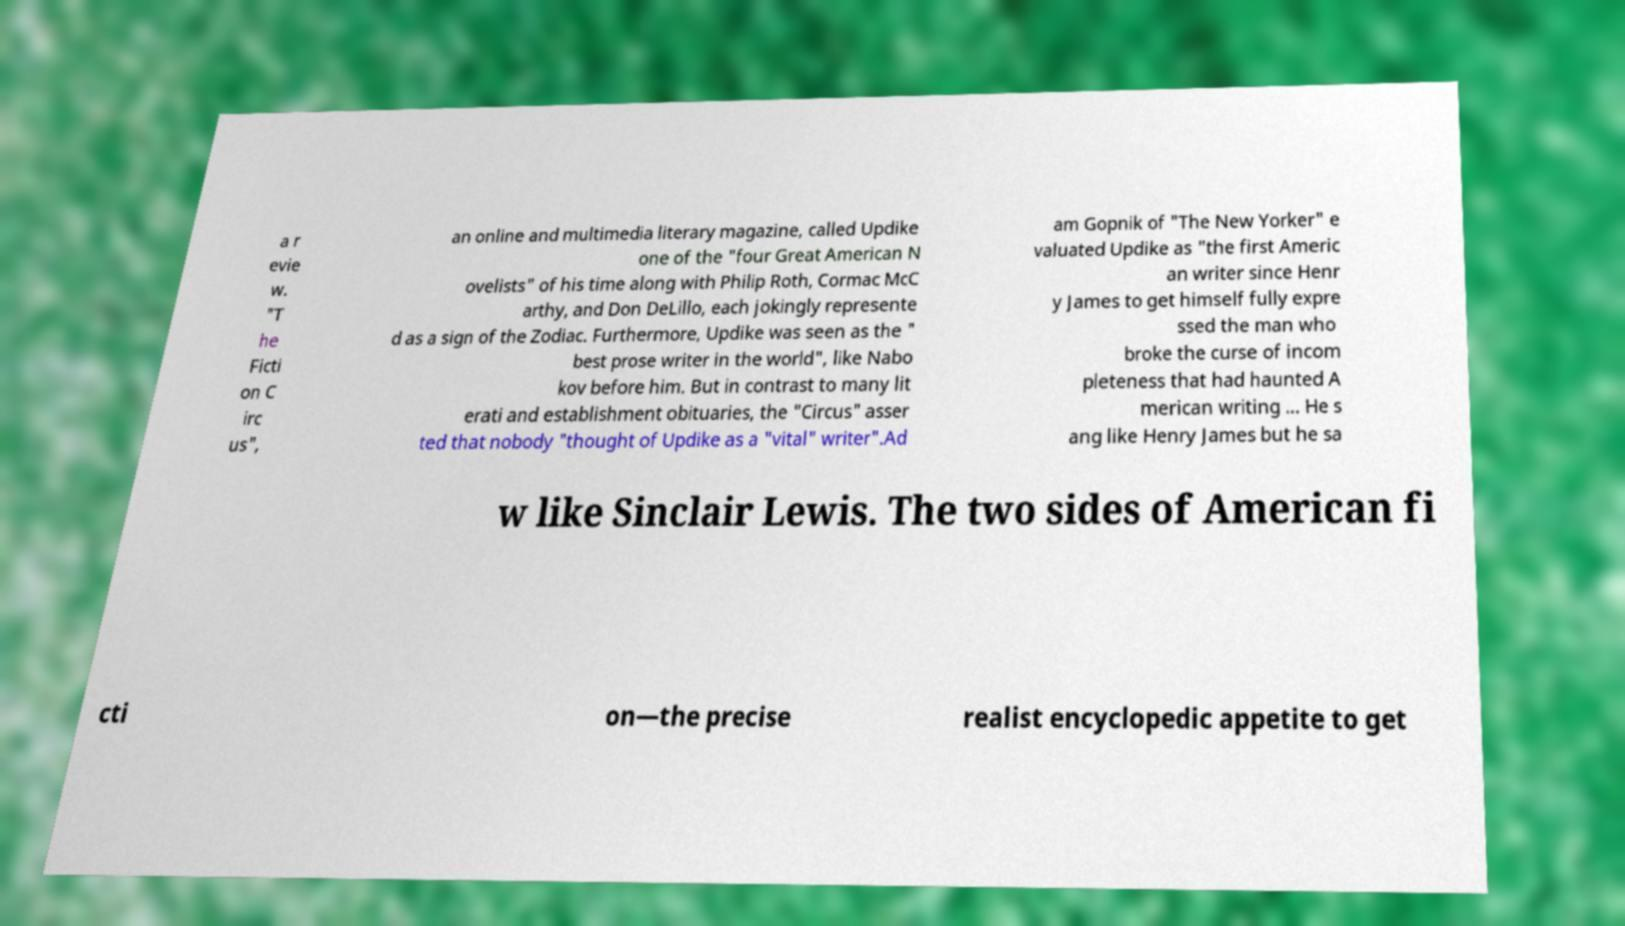Please read and relay the text visible in this image. What does it say? a r evie w. "T he Ficti on C irc us", an online and multimedia literary magazine, called Updike one of the "four Great American N ovelists" of his time along with Philip Roth, Cormac McC arthy, and Don DeLillo, each jokingly represente d as a sign of the Zodiac. Furthermore, Updike was seen as the " best prose writer in the world", like Nabo kov before him. But in contrast to many lit erati and establishment obituaries, the "Circus" asser ted that nobody "thought of Updike as a "vital" writer".Ad am Gopnik of "The New Yorker" e valuated Updike as "the first Americ an writer since Henr y James to get himself fully expre ssed the man who broke the curse of incom pleteness that had haunted A merican writing ... He s ang like Henry James but he sa w like Sinclair Lewis. The two sides of American fi cti on—the precise realist encyclopedic appetite to get 